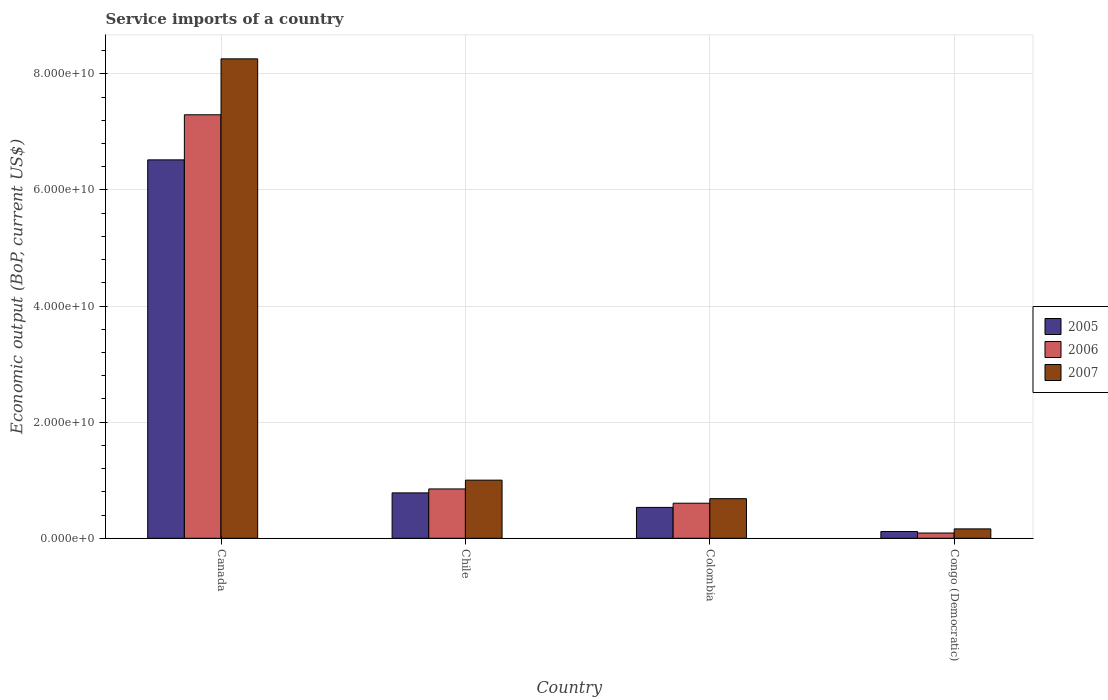How many groups of bars are there?
Offer a very short reply. 4. Are the number of bars per tick equal to the number of legend labels?
Your response must be concise. Yes. How many bars are there on the 2nd tick from the right?
Your response must be concise. 3. In how many cases, is the number of bars for a given country not equal to the number of legend labels?
Offer a very short reply. 0. What is the service imports in 2007 in Congo (Democratic)?
Your response must be concise. 1.62e+09. Across all countries, what is the maximum service imports in 2005?
Your response must be concise. 6.52e+1. Across all countries, what is the minimum service imports in 2006?
Offer a very short reply. 9.06e+08. In which country was the service imports in 2005 minimum?
Your response must be concise. Congo (Democratic). What is the total service imports in 2007 in the graph?
Give a very brief answer. 1.01e+11. What is the difference between the service imports in 2005 in Canada and that in Colombia?
Offer a terse response. 5.99e+1. What is the difference between the service imports in 2006 in Chile and the service imports in 2007 in Canada?
Ensure brevity in your answer.  -7.41e+1. What is the average service imports in 2006 per country?
Keep it short and to the point. 2.21e+1. What is the difference between the service imports of/in 2005 and service imports of/in 2006 in Colombia?
Keep it short and to the point. -7.23e+08. In how many countries, is the service imports in 2005 greater than 56000000000 US$?
Offer a very short reply. 1. What is the ratio of the service imports in 2006 in Canada to that in Chile?
Ensure brevity in your answer.  8.58. Is the service imports in 2006 in Chile less than that in Congo (Democratic)?
Provide a succinct answer. No. Is the difference between the service imports in 2005 in Canada and Chile greater than the difference between the service imports in 2006 in Canada and Chile?
Provide a succinct answer. No. What is the difference between the highest and the second highest service imports in 2005?
Offer a very short reply. 5.74e+1. What is the difference between the highest and the lowest service imports in 2006?
Offer a terse response. 7.20e+1. In how many countries, is the service imports in 2007 greater than the average service imports in 2007 taken over all countries?
Ensure brevity in your answer.  1. What does the 1st bar from the right in Congo (Democratic) represents?
Make the answer very short. 2007. Are all the bars in the graph horizontal?
Offer a terse response. No. Are the values on the major ticks of Y-axis written in scientific E-notation?
Ensure brevity in your answer.  Yes. What is the title of the graph?
Provide a succinct answer. Service imports of a country. Does "1983" appear as one of the legend labels in the graph?
Give a very brief answer. No. What is the label or title of the Y-axis?
Keep it short and to the point. Economic output (BoP, current US$). What is the Economic output (BoP, current US$) of 2005 in Canada?
Keep it short and to the point. 6.52e+1. What is the Economic output (BoP, current US$) of 2006 in Canada?
Provide a succinct answer. 7.29e+1. What is the Economic output (BoP, current US$) in 2007 in Canada?
Your response must be concise. 8.26e+1. What is the Economic output (BoP, current US$) in 2005 in Chile?
Your response must be concise. 7.82e+09. What is the Economic output (BoP, current US$) of 2006 in Chile?
Offer a very short reply. 8.50e+09. What is the Economic output (BoP, current US$) in 2007 in Chile?
Your answer should be compact. 1.00e+1. What is the Economic output (BoP, current US$) in 2005 in Colombia?
Provide a succinct answer. 5.32e+09. What is the Economic output (BoP, current US$) in 2006 in Colombia?
Provide a succinct answer. 6.04e+09. What is the Economic output (BoP, current US$) of 2007 in Colombia?
Your response must be concise. 6.82e+09. What is the Economic output (BoP, current US$) of 2005 in Congo (Democratic)?
Provide a short and direct response. 1.17e+09. What is the Economic output (BoP, current US$) of 2006 in Congo (Democratic)?
Your answer should be very brief. 9.06e+08. What is the Economic output (BoP, current US$) of 2007 in Congo (Democratic)?
Ensure brevity in your answer.  1.62e+09. Across all countries, what is the maximum Economic output (BoP, current US$) in 2005?
Keep it short and to the point. 6.52e+1. Across all countries, what is the maximum Economic output (BoP, current US$) of 2006?
Keep it short and to the point. 7.29e+1. Across all countries, what is the maximum Economic output (BoP, current US$) of 2007?
Your answer should be compact. 8.26e+1. Across all countries, what is the minimum Economic output (BoP, current US$) of 2005?
Give a very brief answer. 1.17e+09. Across all countries, what is the minimum Economic output (BoP, current US$) of 2006?
Your answer should be compact. 9.06e+08. Across all countries, what is the minimum Economic output (BoP, current US$) of 2007?
Keep it short and to the point. 1.62e+09. What is the total Economic output (BoP, current US$) of 2005 in the graph?
Provide a short and direct response. 7.95e+1. What is the total Economic output (BoP, current US$) in 2006 in the graph?
Your response must be concise. 8.84e+1. What is the total Economic output (BoP, current US$) of 2007 in the graph?
Give a very brief answer. 1.01e+11. What is the difference between the Economic output (BoP, current US$) of 2005 in Canada and that in Chile?
Offer a very short reply. 5.74e+1. What is the difference between the Economic output (BoP, current US$) of 2006 in Canada and that in Chile?
Your response must be concise. 6.44e+1. What is the difference between the Economic output (BoP, current US$) of 2007 in Canada and that in Chile?
Give a very brief answer. 7.26e+1. What is the difference between the Economic output (BoP, current US$) in 2005 in Canada and that in Colombia?
Ensure brevity in your answer.  5.99e+1. What is the difference between the Economic output (BoP, current US$) of 2006 in Canada and that in Colombia?
Make the answer very short. 6.69e+1. What is the difference between the Economic output (BoP, current US$) in 2007 in Canada and that in Colombia?
Keep it short and to the point. 7.58e+1. What is the difference between the Economic output (BoP, current US$) in 2005 in Canada and that in Congo (Democratic)?
Offer a terse response. 6.40e+1. What is the difference between the Economic output (BoP, current US$) of 2006 in Canada and that in Congo (Democratic)?
Provide a succinct answer. 7.20e+1. What is the difference between the Economic output (BoP, current US$) of 2007 in Canada and that in Congo (Democratic)?
Ensure brevity in your answer.  8.10e+1. What is the difference between the Economic output (BoP, current US$) of 2005 in Chile and that in Colombia?
Keep it short and to the point. 2.50e+09. What is the difference between the Economic output (BoP, current US$) of 2006 in Chile and that in Colombia?
Provide a succinct answer. 2.46e+09. What is the difference between the Economic output (BoP, current US$) in 2007 in Chile and that in Colombia?
Your answer should be compact. 3.19e+09. What is the difference between the Economic output (BoP, current US$) in 2005 in Chile and that in Congo (Democratic)?
Your answer should be compact. 6.65e+09. What is the difference between the Economic output (BoP, current US$) of 2006 in Chile and that in Congo (Democratic)?
Make the answer very short. 7.59e+09. What is the difference between the Economic output (BoP, current US$) in 2007 in Chile and that in Congo (Democratic)?
Make the answer very short. 8.40e+09. What is the difference between the Economic output (BoP, current US$) of 2005 in Colombia and that in Congo (Democratic)?
Your response must be concise. 4.15e+09. What is the difference between the Economic output (BoP, current US$) in 2006 in Colombia and that in Congo (Democratic)?
Your response must be concise. 5.14e+09. What is the difference between the Economic output (BoP, current US$) of 2007 in Colombia and that in Congo (Democratic)?
Your response must be concise. 5.21e+09. What is the difference between the Economic output (BoP, current US$) of 2005 in Canada and the Economic output (BoP, current US$) of 2006 in Chile?
Your answer should be compact. 5.67e+1. What is the difference between the Economic output (BoP, current US$) in 2005 in Canada and the Economic output (BoP, current US$) in 2007 in Chile?
Provide a succinct answer. 5.52e+1. What is the difference between the Economic output (BoP, current US$) of 2006 in Canada and the Economic output (BoP, current US$) of 2007 in Chile?
Ensure brevity in your answer.  6.29e+1. What is the difference between the Economic output (BoP, current US$) in 2005 in Canada and the Economic output (BoP, current US$) in 2006 in Colombia?
Your answer should be very brief. 5.91e+1. What is the difference between the Economic output (BoP, current US$) in 2005 in Canada and the Economic output (BoP, current US$) in 2007 in Colombia?
Make the answer very short. 5.84e+1. What is the difference between the Economic output (BoP, current US$) in 2006 in Canada and the Economic output (BoP, current US$) in 2007 in Colombia?
Give a very brief answer. 6.61e+1. What is the difference between the Economic output (BoP, current US$) in 2005 in Canada and the Economic output (BoP, current US$) in 2006 in Congo (Democratic)?
Give a very brief answer. 6.43e+1. What is the difference between the Economic output (BoP, current US$) of 2005 in Canada and the Economic output (BoP, current US$) of 2007 in Congo (Democratic)?
Ensure brevity in your answer.  6.36e+1. What is the difference between the Economic output (BoP, current US$) in 2006 in Canada and the Economic output (BoP, current US$) in 2007 in Congo (Democratic)?
Your response must be concise. 7.13e+1. What is the difference between the Economic output (BoP, current US$) of 2005 in Chile and the Economic output (BoP, current US$) of 2006 in Colombia?
Make the answer very short. 1.78e+09. What is the difference between the Economic output (BoP, current US$) of 2005 in Chile and the Economic output (BoP, current US$) of 2007 in Colombia?
Ensure brevity in your answer.  9.94e+08. What is the difference between the Economic output (BoP, current US$) of 2006 in Chile and the Economic output (BoP, current US$) of 2007 in Colombia?
Offer a terse response. 1.67e+09. What is the difference between the Economic output (BoP, current US$) of 2005 in Chile and the Economic output (BoP, current US$) of 2006 in Congo (Democratic)?
Offer a terse response. 6.91e+09. What is the difference between the Economic output (BoP, current US$) of 2005 in Chile and the Economic output (BoP, current US$) of 2007 in Congo (Democratic)?
Your answer should be compact. 6.20e+09. What is the difference between the Economic output (BoP, current US$) in 2006 in Chile and the Economic output (BoP, current US$) in 2007 in Congo (Democratic)?
Your answer should be very brief. 6.88e+09. What is the difference between the Economic output (BoP, current US$) in 2005 in Colombia and the Economic output (BoP, current US$) in 2006 in Congo (Democratic)?
Ensure brevity in your answer.  4.41e+09. What is the difference between the Economic output (BoP, current US$) in 2005 in Colombia and the Economic output (BoP, current US$) in 2007 in Congo (Democratic)?
Offer a very short reply. 3.70e+09. What is the difference between the Economic output (BoP, current US$) of 2006 in Colombia and the Economic output (BoP, current US$) of 2007 in Congo (Democratic)?
Keep it short and to the point. 4.42e+09. What is the average Economic output (BoP, current US$) of 2005 per country?
Keep it short and to the point. 1.99e+1. What is the average Economic output (BoP, current US$) of 2006 per country?
Provide a short and direct response. 2.21e+1. What is the average Economic output (BoP, current US$) in 2007 per country?
Your answer should be very brief. 2.53e+1. What is the difference between the Economic output (BoP, current US$) of 2005 and Economic output (BoP, current US$) of 2006 in Canada?
Offer a terse response. -7.77e+09. What is the difference between the Economic output (BoP, current US$) in 2005 and Economic output (BoP, current US$) in 2007 in Canada?
Give a very brief answer. -1.74e+1. What is the difference between the Economic output (BoP, current US$) in 2006 and Economic output (BoP, current US$) in 2007 in Canada?
Offer a terse response. -9.63e+09. What is the difference between the Economic output (BoP, current US$) of 2005 and Economic output (BoP, current US$) of 2006 in Chile?
Offer a terse response. -6.80e+08. What is the difference between the Economic output (BoP, current US$) of 2005 and Economic output (BoP, current US$) of 2007 in Chile?
Keep it short and to the point. -2.19e+09. What is the difference between the Economic output (BoP, current US$) of 2006 and Economic output (BoP, current US$) of 2007 in Chile?
Your response must be concise. -1.51e+09. What is the difference between the Economic output (BoP, current US$) in 2005 and Economic output (BoP, current US$) in 2006 in Colombia?
Ensure brevity in your answer.  -7.23e+08. What is the difference between the Economic output (BoP, current US$) in 2005 and Economic output (BoP, current US$) in 2007 in Colombia?
Your answer should be compact. -1.51e+09. What is the difference between the Economic output (BoP, current US$) in 2006 and Economic output (BoP, current US$) in 2007 in Colombia?
Your response must be concise. -7.84e+08. What is the difference between the Economic output (BoP, current US$) in 2005 and Economic output (BoP, current US$) in 2006 in Congo (Democratic)?
Your answer should be compact. 2.63e+08. What is the difference between the Economic output (BoP, current US$) in 2005 and Economic output (BoP, current US$) in 2007 in Congo (Democratic)?
Provide a short and direct response. -4.48e+08. What is the difference between the Economic output (BoP, current US$) in 2006 and Economic output (BoP, current US$) in 2007 in Congo (Democratic)?
Ensure brevity in your answer.  -7.12e+08. What is the ratio of the Economic output (BoP, current US$) of 2005 in Canada to that in Chile?
Offer a terse response. 8.34. What is the ratio of the Economic output (BoP, current US$) in 2006 in Canada to that in Chile?
Keep it short and to the point. 8.58. What is the ratio of the Economic output (BoP, current US$) of 2007 in Canada to that in Chile?
Your answer should be compact. 8.25. What is the ratio of the Economic output (BoP, current US$) of 2005 in Canada to that in Colombia?
Your answer should be very brief. 12.25. What is the ratio of the Economic output (BoP, current US$) in 2006 in Canada to that in Colombia?
Provide a short and direct response. 12.07. What is the ratio of the Economic output (BoP, current US$) in 2007 in Canada to that in Colombia?
Your answer should be compact. 12.1. What is the ratio of the Economic output (BoP, current US$) of 2005 in Canada to that in Congo (Democratic)?
Keep it short and to the point. 55.74. What is the ratio of the Economic output (BoP, current US$) in 2006 in Canada to that in Congo (Democratic)?
Your response must be concise. 80.53. What is the ratio of the Economic output (BoP, current US$) of 2007 in Canada to that in Congo (Democratic)?
Give a very brief answer. 51.05. What is the ratio of the Economic output (BoP, current US$) of 2005 in Chile to that in Colombia?
Make the answer very short. 1.47. What is the ratio of the Economic output (BoP, current US$) in 2006 in Chile to that in Colombia?
Provide a succinct answer. 1.41. What is the ratio of the Economic output (BoP, current US$) of 2007 in Chile to that in Colombia?
Ensure brevity in your answer.  1.47. What is the ratio of the Economic output (BoP, current US$) of 2005 in Chile to that in Congo (Democratic)?
Offer a terse response. 6.69. What is the ratio of the Economic output (BoP, current US$) of 2006 in Chile to that in Congo (Democratic)?
Give a very brief answer. 9.38. What is the ratio of the Economic output (BoP, current US$) of 2007 in Chile to that in Congo (Democratic)?
Make the answer very short. 6.19. What is the ratio of the Economic output (BoP, current US$) in 2005 in Colombia to that in Congo (Democratic)?
Your answer should be compact. 4.55. What is the ratio of the Economic output (BoP, current US$) of 2006 in Colombia to that in Congo (Democratic)?
Offer a very short reply. 6.67. What is the ratio of the Economic output (BoP, current US$) of 2007 in Colombia to that in Congo (Democratic)?
Make the answer very short. 4.22. What is the difference between the highest and the second highest Economic output (BoP, current US$) in 2005?
Ensure brevity in your answer.  5.74e+1. What is the difference between the highest and the second highest Economic output (BoP, current US$) of 2006?
Offer a very short reply. 6.44e+1. What is the difference between the highest and the second highest Economic output (BoP, current US$) in 2007?
Keep it short and to the point. 7.26e+1. What is the difference between the highest and the lowest Economic output (BoP, current US$) in 2005?
Make the answer very short. 6.40e+1. What is the difference between the highest and the lowest Economic output (BoP, current US$) of 2006?
Your answer should be compact. 7.20e+1. What is the difference between the highest and the lowest Economic output (BoP, current US$) of 2007?
Give a very brief answer. 8.10e+1. 